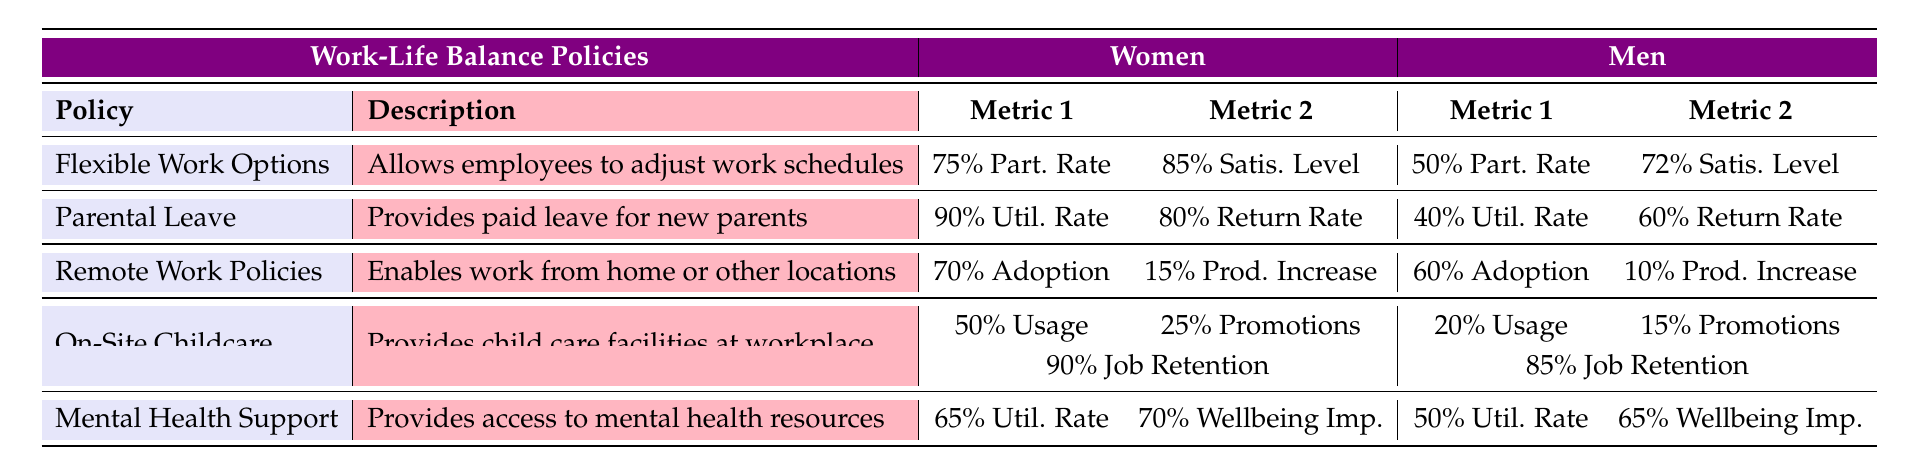What is the satisfaction level of women participating in flexible work options? The table shows that the satisfaction level for women participating in flexible work options is 85%.
Answer: 85% What is the utilization rate of parental leave for men? According to the table, the utilization rate of parental leave for men is 40%.
Answer: 40% Are more women adopting remote work policies than men? Yes, the adoption rate for women is 70%, while for men it is 60%, so more women are adopting remote work policies.
Answer: Yes What is the difference in job retention rates between women and men using on-site childcare? Women have a job retention rate of 90% while men have 85%. The difference is 90% - 85% = 5%.
Answer: 5% Which policy has the highest satisfaction level for women? The flexible work options have the highest satisfaction level for women at 85%, compared to all other policies.
Answer: Flexible Work Options What is the overall average utilization rate of parental leave for both genders? For women, the utilization rate is 90% and for men, it is 40%. The average is (90% + 40%) / 2 = 65%.
Answer: 65% Does the table show that women have a higher productivity increase from remote work than men? Yes, women have a productivity increase of 15% from remote work, while men have an increase of 10%.
Answer: Yes What is the total percentage of participation rates for both genders in flexible work options? Women have a participation rate of 75% and men have a participation rate of 50%. The total is 75% + 50% = 125%.
Answer: 125% What percentage of men report an improvement in wellbeing from mental health support? The table indicates that 65% of men report an improvement in their wellbeing from mental health support.
Answer: 65% 